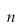<formula> <loc_0><loc_0><loc_500><loc_500>n</formula> 